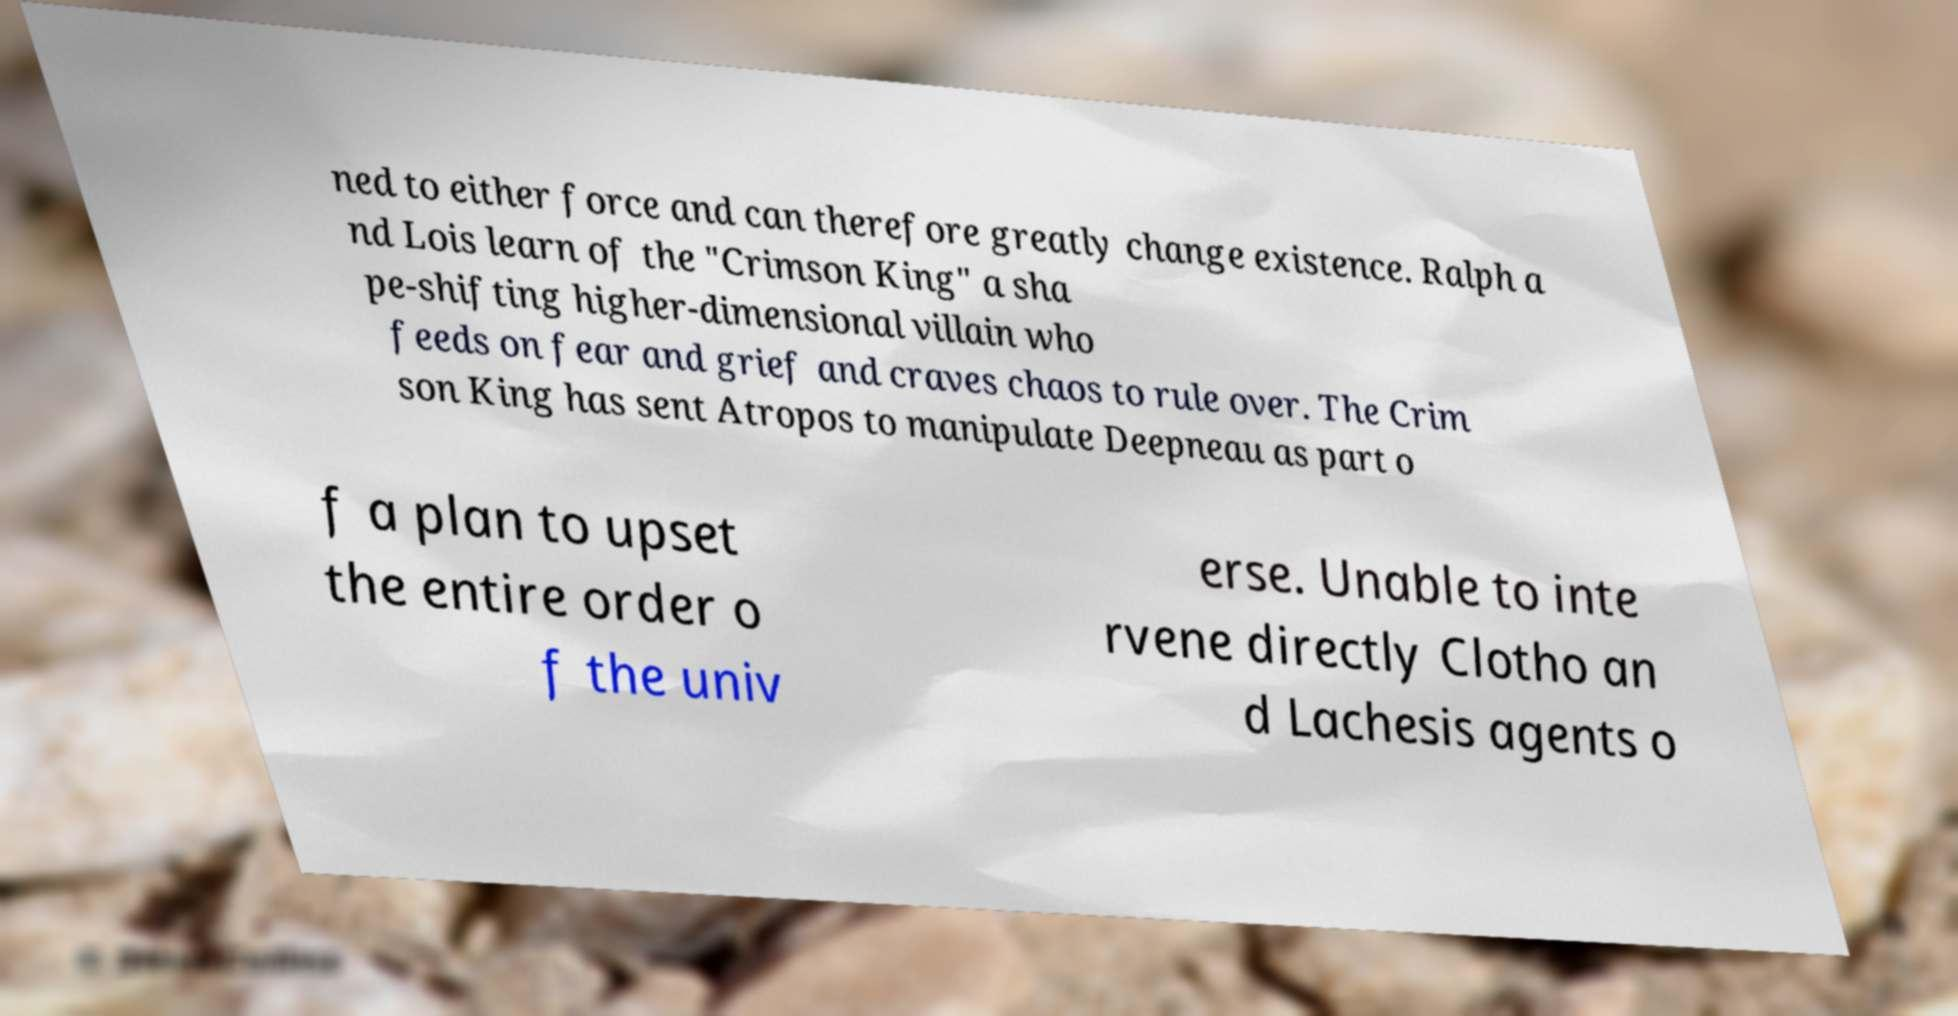Can you read and provide the text displayed in the image?This photo seems to have some interesting text. Can you extract and type it out for me? ned to either force and can therefore greatly change existence. Ralph a nd Lois learn of the "Crimson King" a sha pe-shifting higher-dimensional villain who feeds on fear and grief and craves chaos to rule over. The Crim son King has sent Atropos to manipulate Deepneau as part o f a plan to upset the entire order o f the univ erse. Unable to inte rvene directly Clotho an d Lachesis agents o 